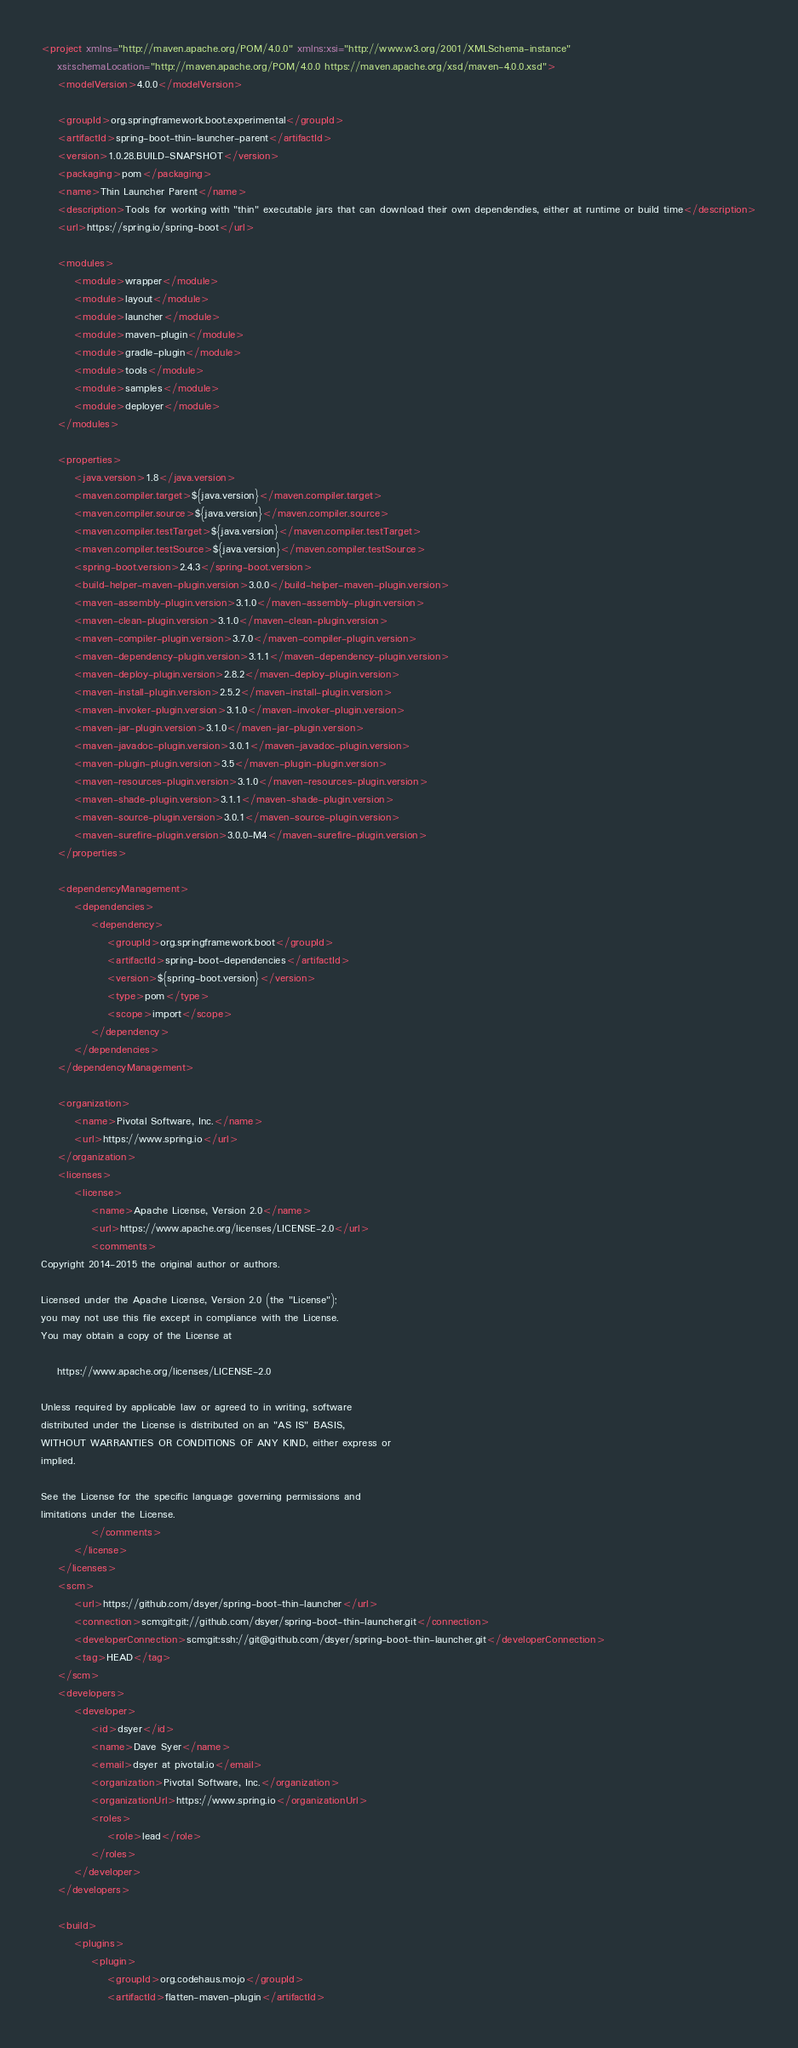Convert code to text. <code><loc_0><loc_0><loc_500><loc_500><_XML_><project xmlns="http://maven.apache.org/POM/4.0.0" xmlns:xsi="http://www.w3.org/2001/XMLSchema-instance"
	xsi:schemaLocation="http://maven.apache.org/POM/4.0.0 https://maven.apache.org/xsd/maven-4.0.0.xsd">
	<modelVersion>4.0.0</modelVersion>

	<groupId>org.springframework.boot.experimental</groupId>
	<artifactId>spring-boot-thin-launcher-parent</artifactId>
	<version>1.0.28.BUILD-SNAPSHOT</version>
	<packaging>pom</packaging>
	<name>Thin Launcher Parent</name>
	<description>Tools for working with "thin" executable jars that can download their own dependendies, either at runtime or build time</description>
	<url>https://spring.io/spring-boot</url>

	<modules>
		<module>wrapper</module>
		<module>layout</module>
		<module>launcher</module>
		<module>maven-plugin</module>
		<module>gradle-plugin</module>
		<module>tools</module>
		<module>samples</module>
		<module>deployer</module>
	</modules>

	<properties>
		<java.version>1.8</java.version>
		<maven.compiler.target>${java.version}</maven.compiler.target>
		<maven.compiler.source>${java.version}</maven.compiler.source>
		<maven.compiler.testTarget>${java.version}</maven.compiler.testTarget>
		<maven.compiler.testSource>${java.version}</maven.compiler.testSource>
		<spring-boot.version>2.4.3</spring-boot.version>
		<build-helper-maven-plugin.version>3.0.0</build-helper-maven-plugin.version>
		<maven-assembly-plugin.version>3.1.0</maven-assembly-plugin.version>
		<maven-clean-plugin.version>3.1.0</maven-clean-plugin.version>
		<maven-compiler-plugin.version>3.7.0</maven-compiler-plugin.version>
		<maven-dependency-plugin.version>3.1.1</maven-dependency-plugin.version>
		<maven-deploy-plugin.version>2.8.2</maven-deploy-plugin.version>
		<maven-install-plugin.version>2.5.2</maven-install-plugin.version>
		<maven-invoker-plugin.version>3.1.0</maven-invoker-plugin.version>
		<maven-jar-plugin.version>3.1.0</maven-jar-plugin.version>
		<maven-javadoc-plugin.version>3.0.1</maven-javadoc-plugin.version>
		<maven-plugin-plugin.version>3.5</maven-plugin-plugin.version>
		<maven-resources-plugin.version>3.1.0</maven-resources-plugin.version>
		<maven-shade-plugin.version>3.1.1</maven-shade-plugin.version>
		<maven-source-plugin.version>3.0.1</maven-source-plugin.version>
		<maven-surefire-plugin.version>3.0.0-M4</maven-surefire-plugin.version>
	</properties>

	<dependencyManagement>
		<dependencies>
			<dependency>
				<groupId>org.springframework.boot</groupId>
				<artifactId>spring-boot-dependencies</artifactId>
				<version>${spring-boot.version}</version>
				<type>pom</type>
				<scope>import</scope>
			</dependency>
		</dependencies>
	</dependencyManagement>

	<organization>
		<name>Pivotal Software, Inc.</name>
		<url>https://www.spring.io</url>
	</organization>
	<licenses>
		<license>
			<name>Apache License, Version 2.0</name>
			<url>https://www.apache.org/licenses/LICENSE-2.0</url>
			<comments>
Copyright 2014-2015 the original author or authors.

Licensed under the Apache License, Version 2.0 (the "License");
you may not use this file except in compliance with the License.
You may obtain a copy of the License at

	https://www.apache.org/licenses/LICENSE-2.0

Unless required by applicable law or agreed to in writing, software
distributed under the License is distributed on an "AS IS" BASIS,
WITHOUT WARRANTIES OR CONDITIONS OF ANY KIND, either express or
implied.

See the License for the specific language governing permissions and
limitations under the License.
			</comments>
		</license>
	</licenses>
	<scm>
		<url>https://github.com/dsyer/spring-boot-thin-launcher</url>
		<connection>scm:git:git://github.com/dsyer/spring-boot-thin-launcher.git</connection>
		<developerConnection>scm:git:ssh://git@github.com/dsyer/spring-boot-thin-launcher.git</developerConnection>
		<tag>HEAD</tag>
	</scm>
	<developers>
		<developer>
			<id>dsyer</id>
			<name>Dave Syer</name>
			<email>dsyer at pivotal.io</email>
			<organization>Pivotal Software, Inc.</organization>
			<organizationUrl>https://www.spring.io</organizationUrl>
			<roles>
				<role>lead</role>
			</roles>
		</developer>
	</developers>

	<build>
		<plugins>
			<plugin>
				<groupId>org.codehaus.mojo</groupId>
				<artifactId>flatten-maven-plugin</artifactId></code> 